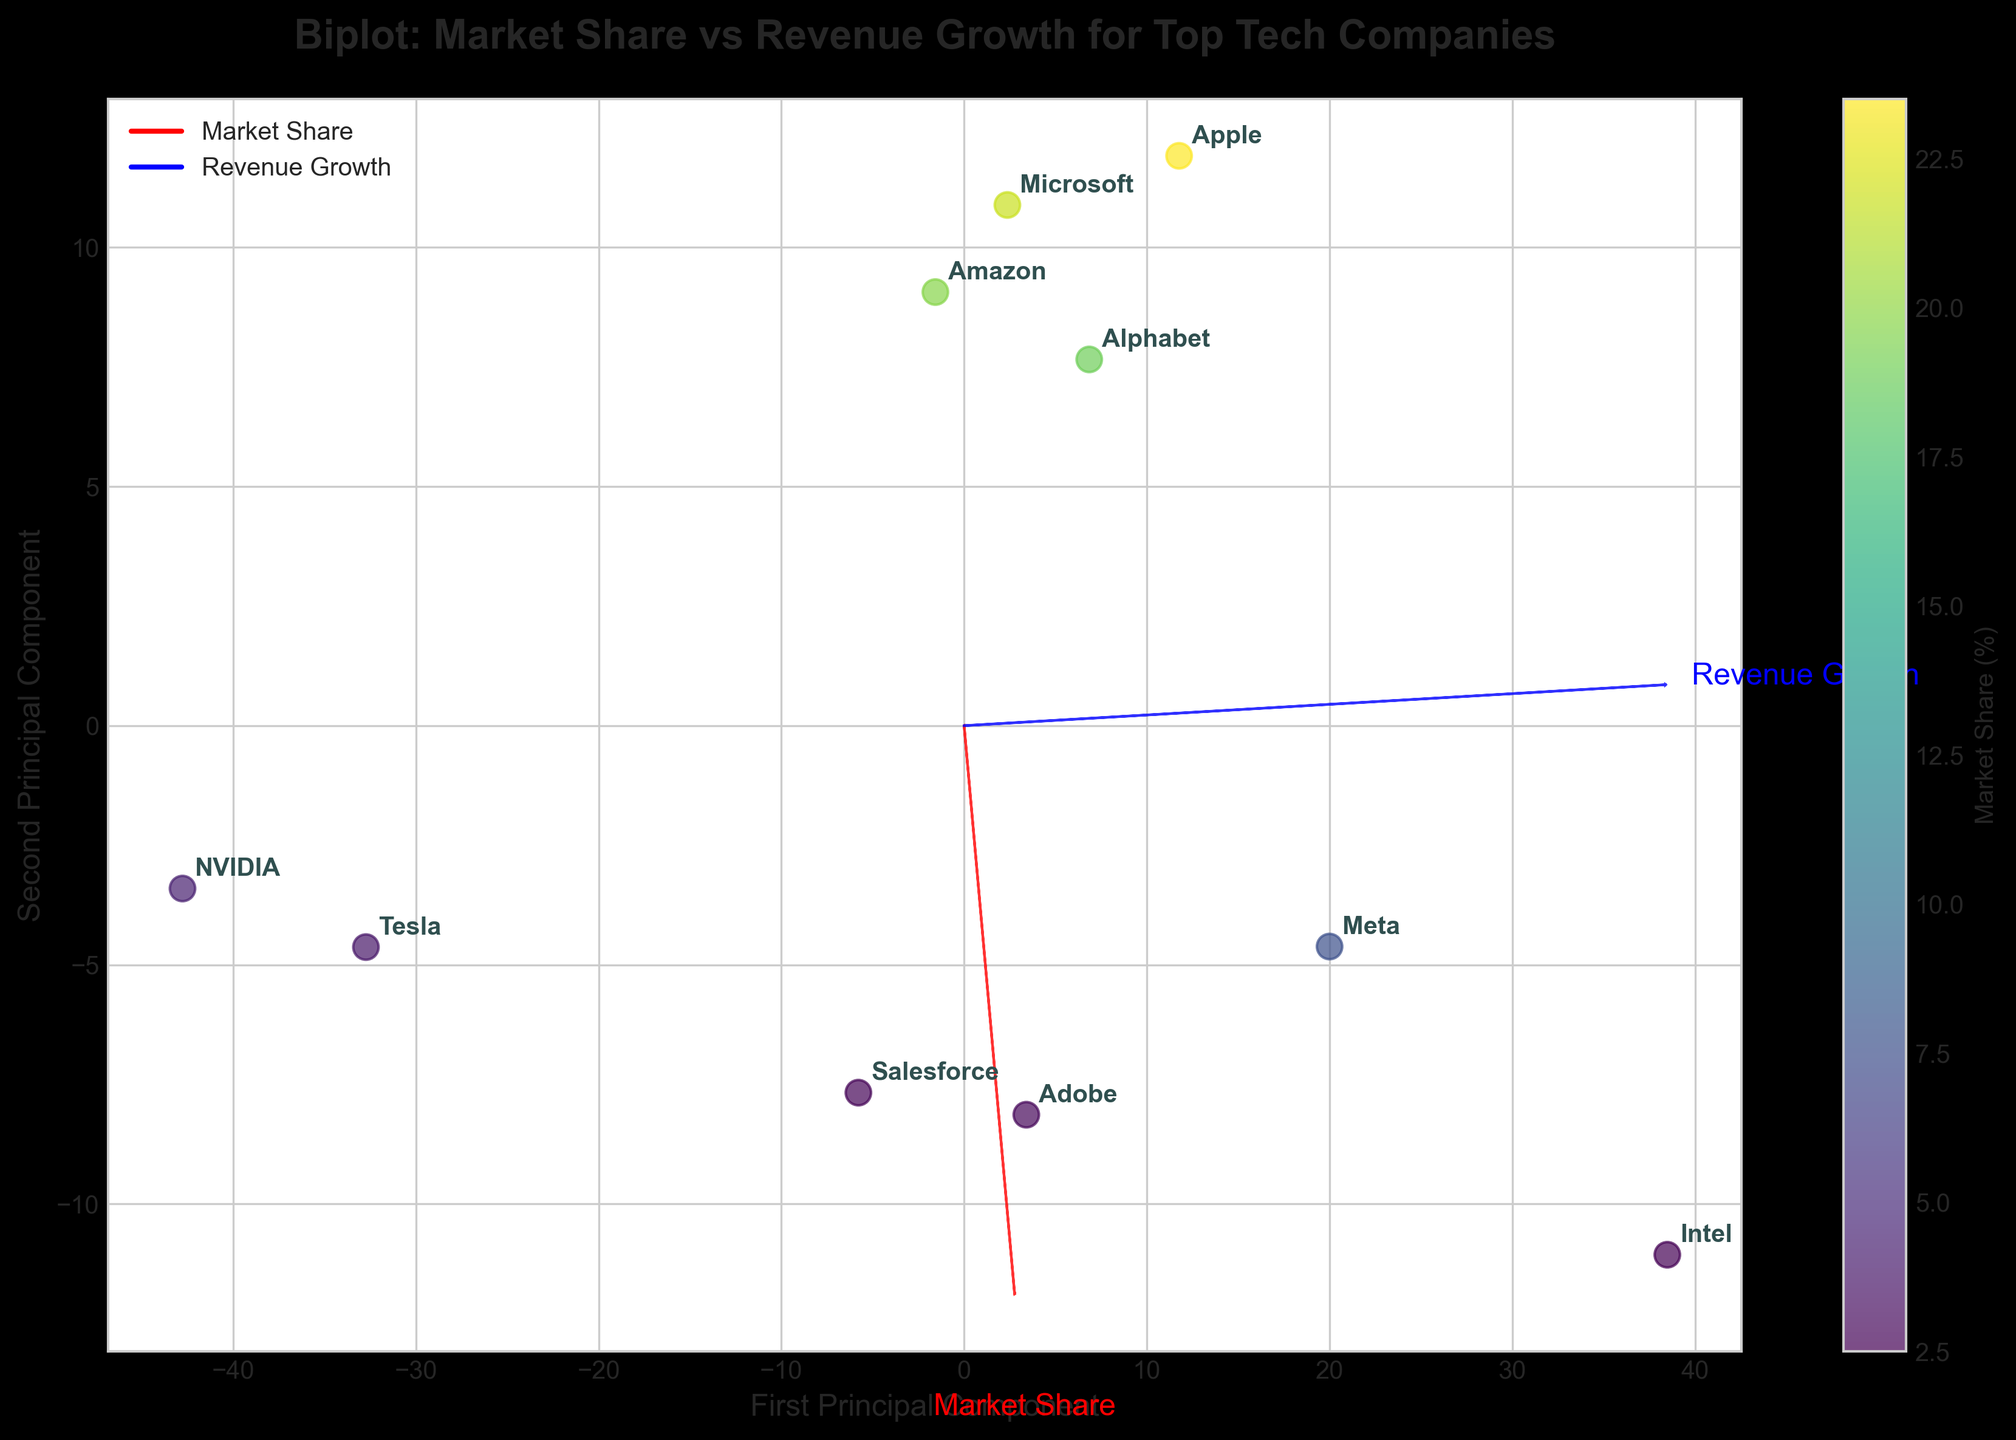Which company has the highest market share? By examining the figure, locate the company label closest to the highest market share value on the color bar and scatter plot.
Answer: Apple Which company has the highest revenue growth? Find the data point with the highest value along the Revenue Growth axis, marked with a label.
Answer: NVIDIA How many companies have a negative revenue growth? Look at the data points positioned below the zero mark on the Revenue Growth axis and count the corresponding company labels.
Answer: 2 Which company has the lowest market share? Identify the data point with the lowest market share value using the color gradient on the scatter plot. The color bar indicates that darker or lighter shades correspond to lower values.
Answer: Intel Which companies have a market share greater than 20%? Identify the data points with colors indicating market shares greater than 20%. Look at the color bar to see which companies fall within this range.
Answer: Apple, Microsoft Compare Apple's position with NVIDIA's on the biplot. Which aspect shows more disparity between the two companies: Market Share or Revenue Growth? Apple is near the top of the First Principal Component for Market Share, whereas NVIDIA is distant along the Second Principal Component for Revenue Growth, indicating a larger discrepancy in Revenue Growth.
Answer: Revenue Growth Is there a pattern between market share and revenue growth? Observe the direction and span of the arrows representing Market Share and Revenue Growth. Check if the arrows point in generally the same or opposite directions for data points close to the origin.
Answer: No clear pattern Which feature vector (Market Share or Revenue Growth) explains more variance in the data? Look at the length of the arrows representing the feature vectors. The longer arrow indicates the feature explaining more variance.
Answer: Market Share What can you infer about Intel's performance from the biplot? Intel is positioned low on both principal components, indicated by its position relative to the axes and color gradient, suggesting low market share and negative revenue growth.
Answer: Poor performance Which feature vector is more aligned with the first principal component? Compare the angles of the arrows representing Market Share and Revenue Growth to the First Principal Component axis. The arrow more aligned parallelly with this axis correlates more with the First Principal Component.
Answer: Market Share 